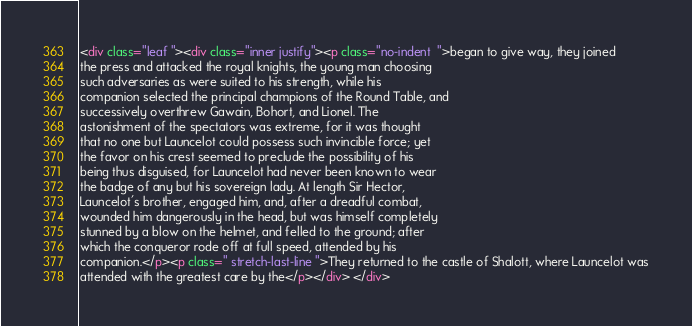Convert code to text. <code><loc_0><loc_0><loc_500><loc_500><_HTML_><div class="leaf "><div class="inner justify"><p class="no-indent  ">began to give way, they joined
the press and attacked the royal knights, the young man choosing
such adversaries as were suited to his strength, while his
companion selected the principal champions of the Round Table, and
successively overthrew Gawain, Bohort, and Lionel. The
astonishment of the spectators was extreme, for it was thought
that no one but Launcelot could possess such invincible force; yet
the favor on his crest seemed to preclude the possibility of his
being thus disguised, for Launcelot had never been known to wear
the badge of any but his sovereign lady. At length Sir Hector,
Launcelot's brother, engaged him, and, after a dreadful combat,
wounded him dangerously in the head, but was himself completely
stunned by a blow on the helmet, and felled to the ground; after
which the conqueror rode off at full speed, attended by his
companion.</p><p class=" stretch-last-line ">They returned to the castle of Shalott, where Launcelot was
attended with the greatest care by the</p></div> </div></code> 